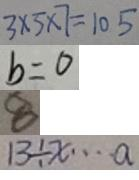<formula> <loc_0><loc_0><loc_500><loc_500>3 \times 5 \times 7 = 1 0 5 
 b = 0 
 8 
 1 3 \div x \cdots a</formula> 